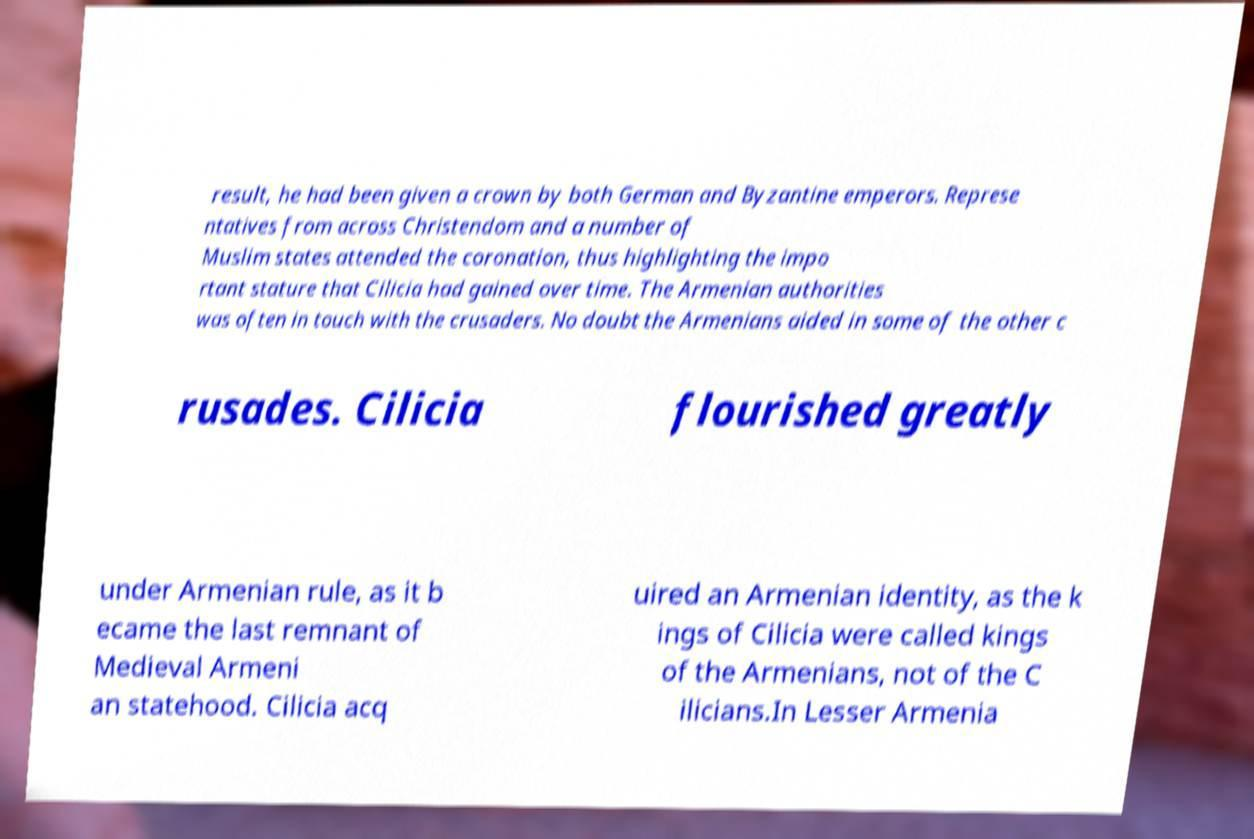Can you read and provide the text displayed in the image?This photo seems to have some interesting text. Can you extract and type it out for me? result, he had been given a crown by both German and Byzantine emperors. Represe ntatives from across Christendom and a number of Muslim states attended the coronation, thus highlighting the impo rtant stature that Cilicia had gained over time. The Armenian authorities was often in touch with the crusaders. No doubt the Armenians aided in some of the other c rusades. Cilicia flourished greatly under Armenian rule, as it b ecame the last remnant of Medieval Armeni an statehood. Cilicia acq uired an Armenian identity, as the k ings of Cilicia were called kings of the Armenians, not of the C ilicians.In Lesser Armenia 